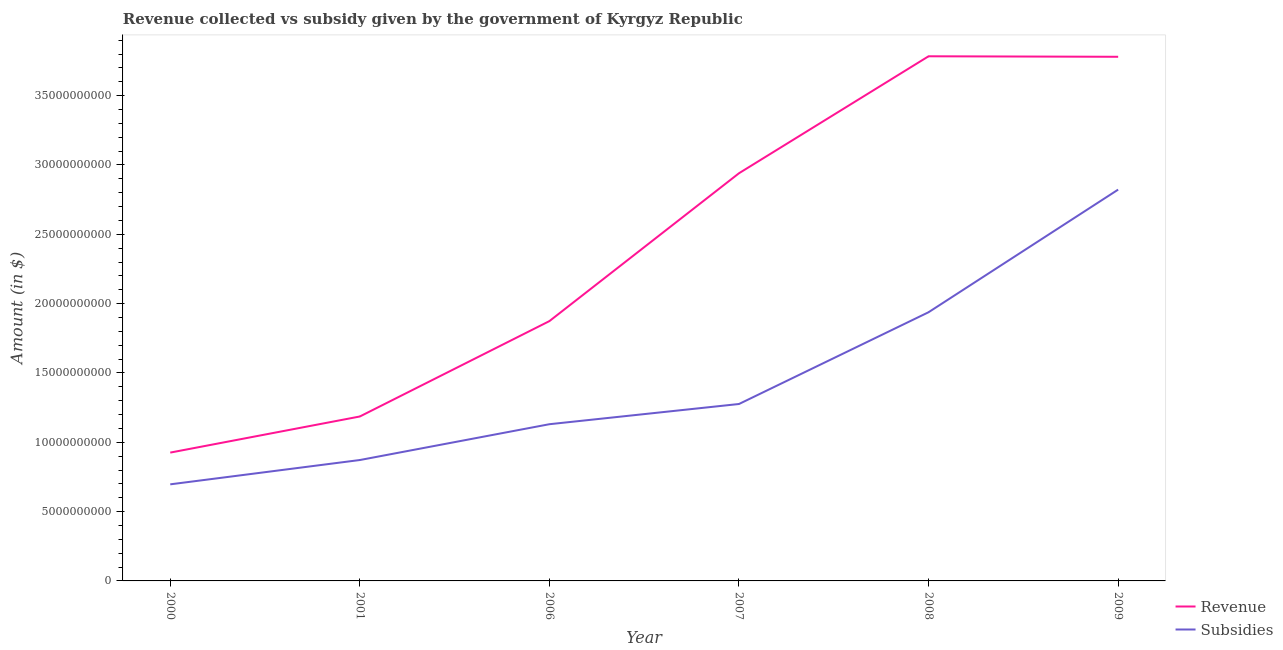How many different coloured lines are there?
Provide a short and direct response. 2. Does the line corresponding to amount of revenue collected intersect with the line corresponding to amount of subsidies given?
Ensure brevity in your answer.  No. What is the amount of subsidies given in 2009?
Provide a short and direct response. 2.82e+1. Across all years, what is the maximum amount of revenue collected?
Ensure brevity in your answer.  3.78e+1. Across all years, what is the minimum amount of subsidies given?
Keep it short and to the point. 6.97e+09. In which year was the amount of revenue collected maximum?
Provide a succinct answer. 2008. What is the total amount of revenue collected in the graph?
Your answer should be very brief. 1.45e+11. What is the difference between the amount of subsidies given in 2008 and that in 2009?
Offer a very short reply. -8.84e+09. What is the difference between the amount of subsidies given in 2009 and the amount of revenue collected in 2006?
Provide a succinct answer. 9.48e+09. What is the average amount of subsidies given per year?
Make the answer very short. 1.46e+1. In the year 2006, what is the difference between the amount of subsidies given and amount of revenue collected?
Your response must be concise. -7.44e+09. In how many years, is the amount of subsidies given greater than 18000000000 $?
Make the answer very short. 2. What is the ratio of the amount of subsidies given in 2001 to that in 2009?
Provide a succinct answer. 0.31. Is the amount of revenue collected in 2007 less than that in 2009?
Give a very brief answer. Yes. Is the difference between the amount of subsidies given in 2001 and 2008 greater than the difference between the amount of revenue collected in 2001 and 2008?
Ensure brevity in your answer.  Yes. What is the difference between the highest and the second highest amount of revenue collected?
Make the answer very short. 3.67e+07. What is the difference between the highest and the lowest amount of revenue collected?
Ensure brevity in your answer.  2.86e+1. Does the amount of subsidies given monotonically increase over the years?
Keep it short and to the point. Yes. Is the amount of subsidies given strictly greater than the amount of revenue collected over the years?
Keep it short and to the point. No. Is the amount of subsidies given strictly less than the amount of revenue collected over the years?
Make the answer very short. Yes. How many lines are there?
Your answer should be compact. 2. What is the difference between two consecutive major ticks on the Y-axis?
Offer a terse response. 5.00e+09. Does the graph contain grids?
Ensure brevity in your answer.  No. How many legend labels are there?
Your answer should be very brief. 2. What is the title of the graph?
Ensure brevity in your answer.  Revenue collected vs subsidy given by the government of Kyrgyz Republic. What is the label or title of the Y-axis?
Your answer should be compact. Amount (in $). What is the Amount (in $) of Revenue in 2000?
Offer a very short reply. 9.26e+09. What is the Amount (in $) of Subsidies in 2000?
Keep it short and to the point. 6.97e+09. What is the Amount (in $) in Revenue in 2001?
Ensure brevity in your answer.  1.19e+1. What is the Amount (in $) of Subsidies in 2001?
Keep it short and to the point. 8.72e+09. What is the Amount (in $) in Revenue in 2006?
Your response must be concise. 1.87e+1. What is the Amount (in $) in Subsidies in 2006?
Give a very brief answer. 1.13e+1. What is the Amount (in $) of Revenue in 2007?
Your answer should be compact. 2.94e+1. What is the Amount (in $) in Subsidies in 2007?
Give a very brief answer. 1.28e+1. What is the Amount (in $) in Revenue in 2008?
Offer a terse response. 3.78e+1. What is the Amount (in $) of Subsidies in 2008?
Provide a succinct answer. 1.94e+1. What is the Amount (in $) in Revenue in 2009?
Give a very brief answer. 3.78e+1. What is the Amount (in $) of Subsidies in 2009?
Offer a very short reply. 2.82e+1. Across all years, what is the maximum Amount (in $) of Revenue?
Your answer should be very brief. 3.78e+1. Across all years, what is the maximum Amount (in $) in Subsidies?
Ensure brevity in your answer.  2.82e+1. Across all years, what is the minimum Amount (in $) of Revenue?
Your answer should be compact. 9.26e+09. Across all years, what is the minimum Amount (in $) of Subsidies?
Your answer should be very brief. 6.97e+09. What is the total Amount (in $) of Revenue in the graph?
Give a very brief answer. 1.45e+11. What is the total Amount (in $) in Subsidies in the graph?
Offer a very short reply. 8.74e+1. What is the difference between the Amount (in $) in Revenue in 2000 and that in 2001?
Make the answer very short. -2.60e+09. What is the difference between the Amount (in $) in Subsidies in 2000 and that in 2001?
Provide a succinct answer. -1.75e+09. What is the difference between the Amount (in $) of Revenue in 2000 and that in 2006?
Your answer should be compact. -9.48e+09. What is the difference between the Amount (in $) in Subsidies in 2000 and that in 2006?
Provide a succinct answer. -4.34e+09. What is the difference between the Amount (in $) in Revenue in 2000 and that in 2007?
Give a very brief answer. -2.01e+1. What is the difference between the Amount (in $) of Subsidies in 2000 and that in 2007?
Your answer should be very brief. -5.79e+09. What is the difference between the Amount (in $) in Revenue in 2000 and that in 2008?
Ensure brevity in your answer.  -2.86e+1. What is the difference between the Amount (in $) of Subsidies in 2000 and that in 2008?
Offer a terse response. -1.24e+1. What is the difference between the Amount (in $) of Revenue in 2000 and that in 2009?
Give a very brief answer. -2.85e+1. What is the difference between the Amount (in $) in Subsidies in 2000 and that in 2009?
Ensure brevity in your answer.  -2.13e+1. What is the difference between the Amount (in $) of Revenue in 2001 and that in 2006?
Offer a terse response. -6.88e+09. What is the difference between the Amount (in $) in Subsidies in 2001 and that in 2006?
Offer a terse response. -2.58e+09. What is the difference between the Amount (in $) in Revenue in 2001 and that in 2007?
Provide a succinct answer. -1.75e+1. What is the difference between the Amount (in $) in Subsidies in 2001 and that in 2007?
Provide a short and direct response. -4.04e+09. What is the difference between the Amount (in $) in Revenue in 2001 and that in 2008?
Offer a terse response. -2.60e+1. What is the difference between the Amount (in $) of Subsidies in 2001 and that in 2008?
Provide a short and direct response. -1.07e+1. What is the difference between the Amount (in $) in Revenue in 2001 and that in 2009?
Provide a succinct answer. -2.59e+1. What is the difference between the Amount (in $) in Subsidies in 2001 and that in 2009?
Keep it short and to the point. -1.95e+1. What is the difference between the Amount (in $) in Revenue in 2006 and that in 2007?
Your response must be concise. -1.07e+1. What is the difference between the Amount (in $) of Subsidies in 2006 and that in 2007?
Your answer should be very brief. -1.46e+09. What is the difference between the Amount (in $) of Revenue in 2006 and that in 2008?
Your answer should be very brief. -1.91e+1. What is the difference between the Amount (in $) in Subsidies in 2006 and that in 2008?
Give a very brief answer. -8.08e+09. What is the difference between the Amount (in $) of Revenue in 2006 and that in 2009?
Give a very brief answer. -1.91e+1. What is the difference between the Amount (in $) of Subsidies in 2006 and that in 2009?
Ensure brevity in your answer.  -1.69e+1. What is the difference between the Amount (in $) in Revenue in 2007 and that in 2008?
Keep it short and to the point. -8.44e+09. What is the difference between the Amount (in $) in Subsidies in 2007 and that in 2008?
Offer a very short reply. -6.62e+09. What is the difference between the Amount (in $) in Revenue in 2007 and that in 2009?
Give a very brief answer. -8.40e+09. What is the difference between the Amount (in $) of Subsidies in 2007 and that in 2009?
Give a very brief answer. -1.55e+1. What is the difference between the Amount (in $) in Revenue in 2008 and that in 2009?
Your response must be concise. 3.67e+07. What is the difference between the Amount (in $) in Subsidies in 2008 and that in 2009?
Offer a terse response. -8.84e+09. What is the difference between the Amount (in $) of Revenue in 2000 and the Amount (in $) of Subsidies in 2001?
Your answer should be compact. 5.37e+08. What is the difference between the Amount (in $) of Revenue in 2000 and the Amount (in $) of Subsidies in 2006?
Offer a terse response. -2.05e+09. What is the difference between the Amount (in $) in Revenue in 2000 and the Amount (in $) in Subsidies in 2007?
Keep it short and to the point. -3.50e+09. What is the difference between the Amount (in $) in Revenue in 2000 and the Amount (in $) in Subsidies in 2008?
Your answer should be very brief. -1.01e+1. What is the difference between the Amount (in $) of Revenue in 2000 and the Amount (in $) of Subsidies in 2009?
Your answer should be very brief. -1.90e+1. What is the difference between the Amount (in $) in Revenue in 2001 and the Amount (in $) in Subsidies in 2006?
Ensure brevity in your answer.  5.57e+08. What is the difference between the Amount (in $) of Revenue in 2001 and the Amount (in $) of Subsidies in 2007?
Your answer should be very brief. -9.01e+08. What is the difference between the Amount (in $) of Revenue in 2001 and the Amount (in $) of Subsidies in 2008?
Your answer should be compact. -7.52e+09. What is the difference between the Amount (in $) in Revenue in 2001 and the Amount (in $) in Subsidies in 2009?
Provide a short and direct response. -1.64e+1. What is the difference between the Amount (in $) of Revenue in 2006 and the Amount (in $) of Subsidies in 2007?
Your answer should be very brief. 5.98e+09. What is the difference between the Amount (in $) of Revenue in 2006 and the Amount (in $) of Subsidies in 2008?
Ensure brevity in your answer.  -6.41e+08. What is the difference between the Amount (in $) of Revenue in 2006 and the Amount (in $) of Subsidies in 2009?
Offer a terse response. -9.48e+09. What is the difference between the Amount (in $) in Revenue in 2007 and the Amount (in $) in Subsidies in 2008?
Your response must be concise. 1.00e+1. What is the difference between the Amount (in $) of Revenue in 2007 and the Amount (in $) of Subsidies in 2009?
Provide a short and direct response. 1.18e+09. What is the difference between the Amount (in $) of Revenue in 2008 and the Amount (in $) of Subsidies in 2009?
Offer a terse response. 9.62e+09. What is the average Amount (in $) of Revenue per year?
Ensure brevity in your answer.  2.42e+1. What is the average Amount (in $) of Subsidies per year?
Give a very brief answer. 1.46e+1. In the year 2000, what is the difference between the Amount (in $) of Revenue and Amount (in $) of Subsidies?
Offer a very short reply. 2.29e+09. In the year 2001, what is the difference between the Amount (in $) of Revenue and Amount (in $) of Subsidies?
Ensure brevity in your answer.  3.14e+09. In the year 2006, what is the difference between the Amount (in $) of Revenue and Amount (in $) of Subsidies?
Give a very brief answer. 7.44e+09. In the year 2007, what is the difference between the Amount (in $) of Revenue and Amount (in $) of Subsidies?
Ensure brevity in your answer.  1.66e+1. In the year 2008, what is the difference between the Amount (in $) in Revenue and Amount (in $) in Subsidies?
Ensure brevity in your answer.  1.85e+1. In the year 2009, what is the difference between the Amount (in $) of Revenue and Amount (in $) of Subsidies?
Your answer should be very brief. 9.58e+09. What is the ratio of the Amount (in $) of Revenue in 2000 to that in 2001?
Ensure brevity in your answer.  0.78. What is the ratio of the Amount (in $) of Subsidies in 2000 to that in 2001?
Provide a short and direct response. 0.8. What is the ratio of the Amount (in $) of Revenue in 2000 to that in 2006?
Your answer should be compact. 0.49. What is the ratio of the Amount (in $) in Subsidies in 2000 to that in 2006?
Your answer should be very brief. 0.62. What is the ratio of the Amount (in $) of Revenue in 2000 to that in 2007?
Ensure brevity in your answer.  0.31. What is the ratio of the Amount (in $) in Subsidies in 2000 to that in 2007?
Provide a short and direct response. 0.55. What is the ratio of the Amount (in $) of Revenue in 2000 to that in 2008?
Offer a terse response. 0.24. What is the ratio of the Amount (in $) in Subsidies in 2000 to that in 2008?
Offer a terse response. 0.36. What is the ratio of the Amount (in $) in Revenue in 2000 to that in 2009?
Offer a very short reply. 0.24. What is the ratio of the Amount (in $) of Subsidies in 2000 to that in 2009?
Offer a very short reply. 0.25. What is the ratio of the Amount (in $) of Revenue in 2001 to that in 2006?
Keep it short and to the point. 0.63. What is the ratio of the Amount (in $) in Subsidies in 2001 to that in 2006?
Provide a short and direct response. 0.77. What is the ratio of the Amount (in $) of Revenue in 2001 to that in 2007?
Make the answer very short. 0.4. What is the ratio of the Amount (in $) in Subsidies in 2001 to that in 2007?
Ensure brevity in your answer.  0.68. What is the ratio of the Amount (in $) in Revenue in 2001 to that in 2008?
Your response must be concise. 0.31. What is the ratio of the Amount (in $) of Subsidies in 2001 to that in 2008?
Give a very brief answer. 0.45. What is the ratio of the Amount (in $) of Revenue in 2001 to that in 2009?
Give a very brief answer. 0.31. What is the ratio of the Amount (in $) of Subsidies in 2001 to that in 2009?
Your answer should be compact. 0.31. What is the ratio of the Amount (in $) of Revenue in 2006 to that in 2007?
Give a very brief answer. 0.64. What is the ratio of the Amount (in $) of Subsidies in 2006 to that in 2007?
Ensure brevity in your answer.  0.89. What is the ratio of the Amount (in $) in Revenue in 2006 to that in 2008?
Give a very brief answer. 0.5. What is the ratio of the Amount (in $) in Subsidies in 2006 to that in 2008?
Ensure brevity in your answer.  0.58. What is the ratio of the Amount (in $) in Revenue in 2006 to that in 2009?
Your answer should be compact. 0.5. What is the ratio of the Amount (in $) in Subsidies in 2006 to that in 2009?
Give a very brief answer. 0.4. What is the ratio of the Amount (in $) of Revenue in 2007 to that in 2008?
Provide a succinct answer. 0.78. What is the ratio of the Amount (in $) of Subsidies in 2007 to that in 2008?
Your answer should be compact. 0.66. What is the ratio of the Amount (in $) in Revenue in 2007 to that in 2009?
Keep it short and to the point. 0.78. What is the ratio of the Amount (in $) of Subsidies in 2007 to that in 2009?
Keep it short and to the point. 0.45. What is the ratio of the Amount (in $) in Revenue in 2008 to that in 2009?
Offer a very short reply. 1. What is the ratio of the Amount (in $) in Subsidies in 2008 to that in 2009?
Your response must be concise. 0.69. What is the difference between the highest and the second highest Amount (in $) of Revenue?
Provide a succinct answer. 3.67e+07. What is the difference between the highest and the second highest Amount (in $) of Subsidies?
Offer a terse response. 8.84e+09. What is the difference between the highest and the lowest Amount (in $) of Revenue?
Your answer should be very brief. 2.86e+1. What is the difference between the highest and the lowest Amount (in $) of Subsidies?
Make the answer very short. 2.13e+1. 